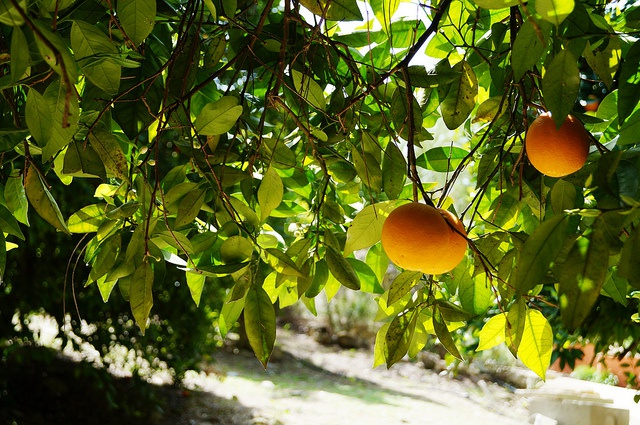Describe the objects in this image and their specific colors. I can see orange in darkgreen, orange, maroon, and red tones, orange in darkgreen, maroon, orange, and black tones, orange in darkgreen, orange, brown, and gold tones, and orange in darkgreen, brown, maroon, and black tones in this image. 